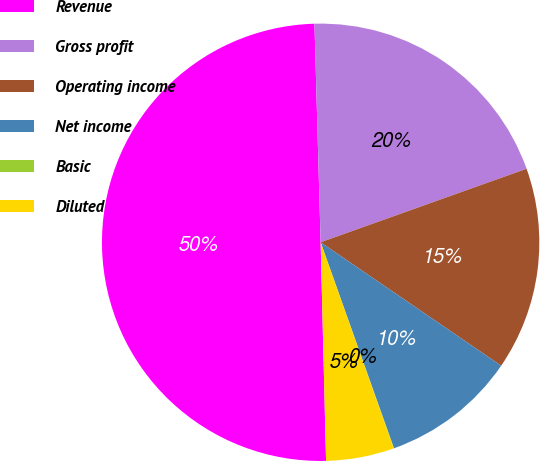Convert chart to OTSL. <chart><loc_0><loc_0><loc_500><loc_500><pie_chart><fcel>Revenue<fcel>Gross profit<fcel>Operating income<fcel>Net income<fcel>Basic<fcel>Diluted<nl><fcel>49.94%<fcel>19.99%<fcel>15.0%<fcel>10.01%<fcel>0.03%<fcel>5.02%<nl></chart> 